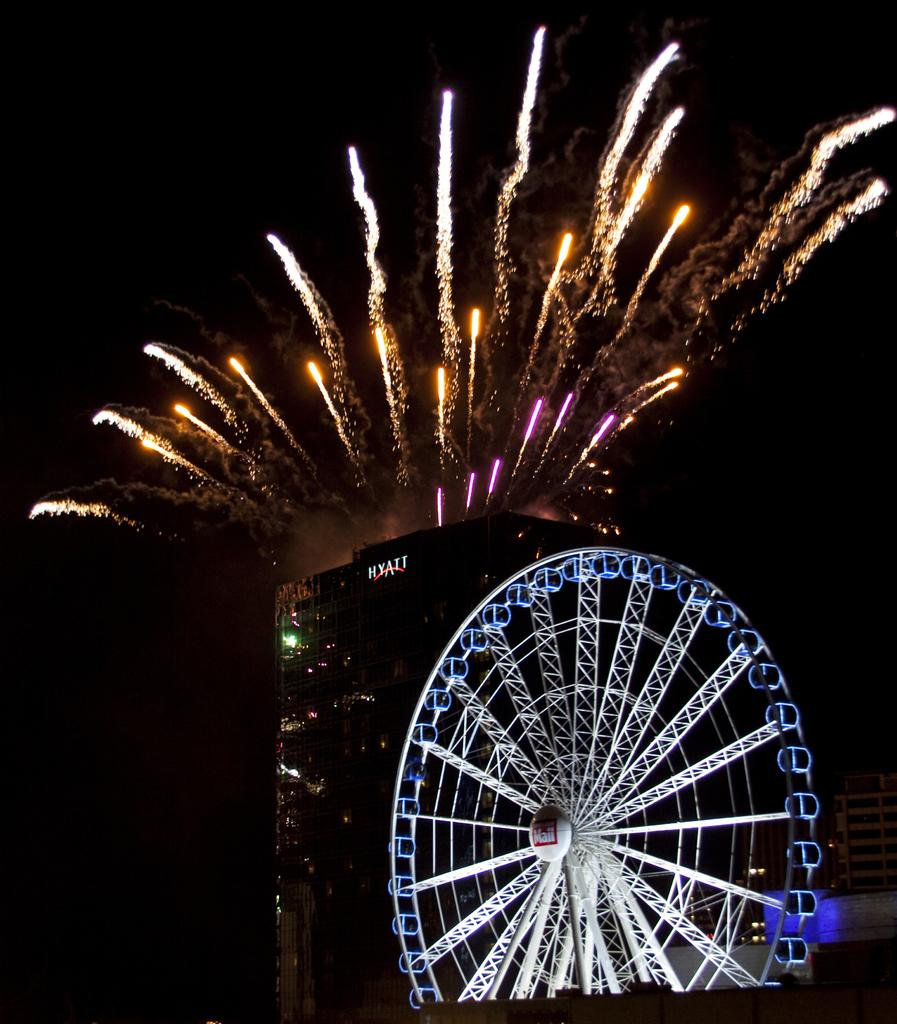What type of visual effect can be seen in the image? There are sparkles in the image. What type of structure is present in the image? There is a building in the image. What type of amusement ride can be seen in the image? There is a giant wheel in the image. What is written on the building in the image? There is writing on the building in the image. What type of juice is being served in the image? There is no juice present in the image. What is the color of the wristband in the image? There is no wristband present in the image. 